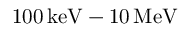<formula> <loc_0><loc_0><loc_500><loc_500>1 0 0 \, k e V - 1 0 \, \mathrm { M e V }</formula> 